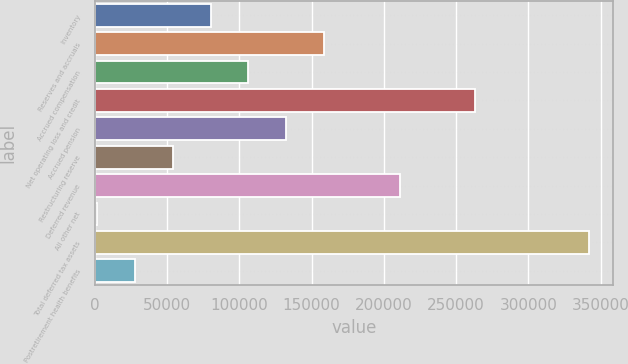Convert chart. <chart><loc_0><loc_0><loc_500><loc_500><bar_chart><fcel>Inventory<fcel>Reserves and accruals<fcel>Accrued compensation<fcel>Net operating loss and credit<fcel>Accrued pension<fcel>Restructuring reserve<fcel>Deferred revenue<fcel>All other net<fcel>Total deferred tax assets<fcel>Postretirement health benefits<nl><fcel>80158.6<fcel>158651<fcel>106323<fcel>263308<fcel>132487<fcel>53994.4<fcel>210980<fcel>1666<fcel>341801<fcel>27830.2<nl></chart> 